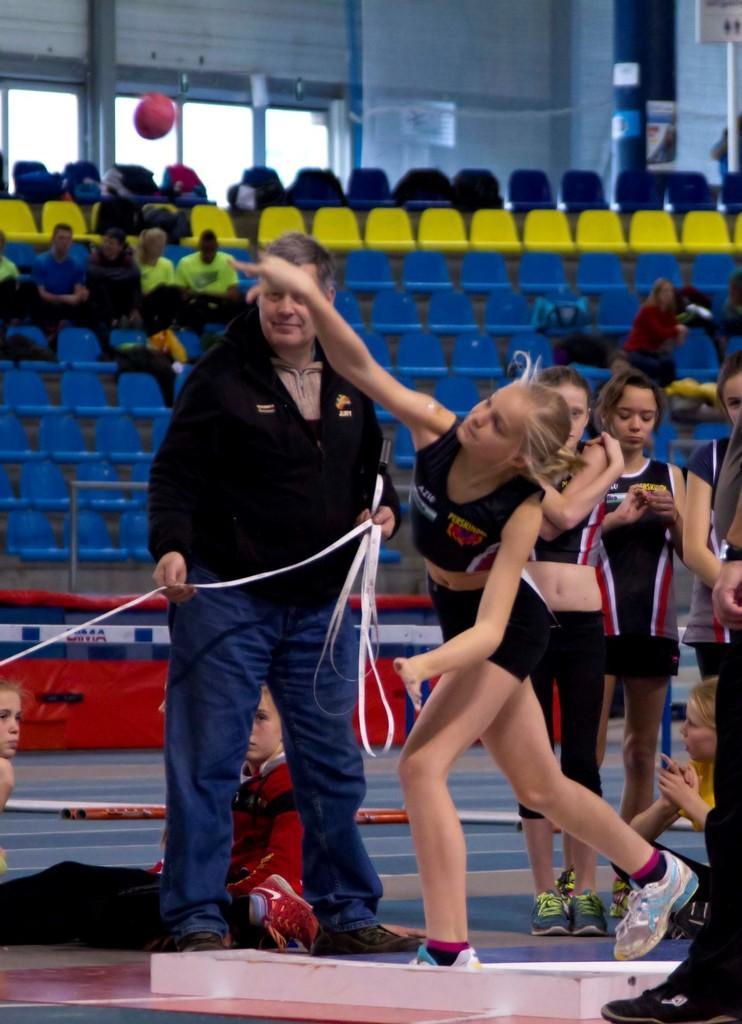Can you describe this image briefly? In this image we can see many people. One person is holding a tape. In the background there are chairs. Few people are sitting. Also we can see a shot put. In the background there are windows, 